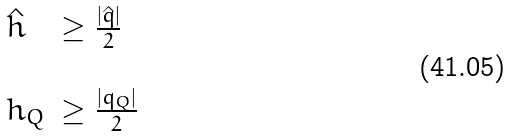<formula> <loc_0><loc_0><loc_500><loc_500>\begin{array} { l l } \hat { h } & \geq \frac { | \hat { q } | } { 2 } \\ & \\ h _ { Q } & \geq \frac { | q _ { Q } | } { 2 } \end{array}</formula> 